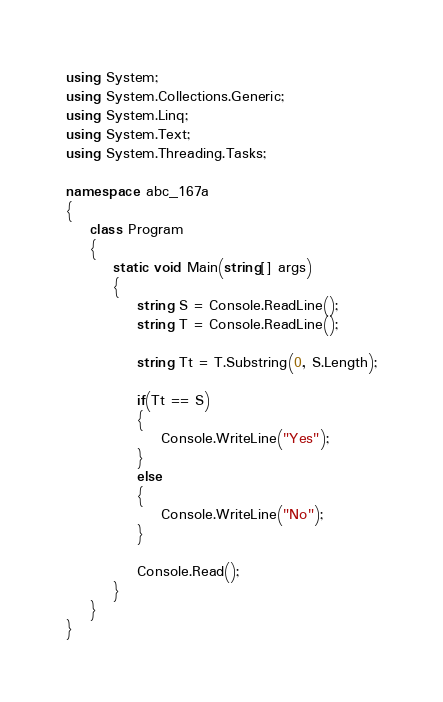Convert code to text. <code><loc_0><loc_0><loc_500><loc_500><_C#_>using System;
using System.Collections.Generic;
using System.Linq;
using System.Text;
using System.Threading.Tasks;

namespace abc_167a
{
    class Program
    {
        static void Main(string[] args)
        {
            string S = Console.ReadLine();
            string T = Console.ReadLine();

            string Tt = T.Substring(0, S.Length);

            if(Tt == S)
            {
                Console.WriteLine("Yes");
            }
            else
            {
                Console.WriteLine("No");
            }

            Console.Read();
        }
    }
}
</code> 